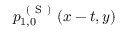<formula> <loc_0><loc_0><loc_500><loc_500>p _ { 1 , 0 } ^ { ( S ) } ( x - t , y )</formula> 